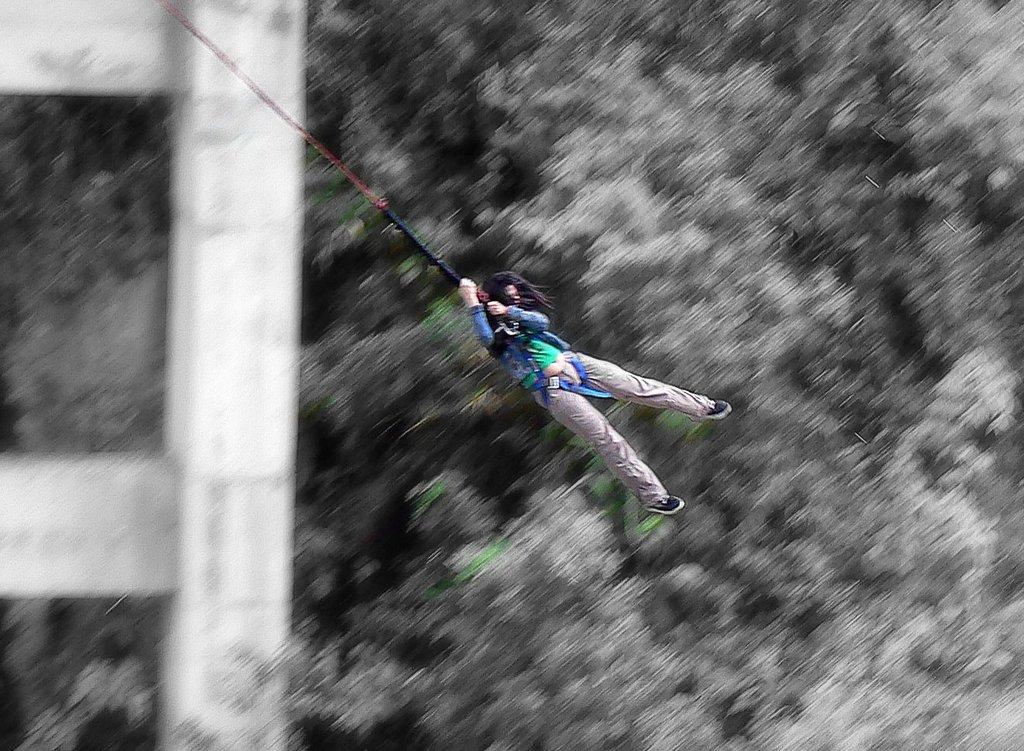Could you give a brief overview of what you see in this image? In the center of the picture there is a person doing bungee jump. In the background there are trees and pillar. The background is blurred. 